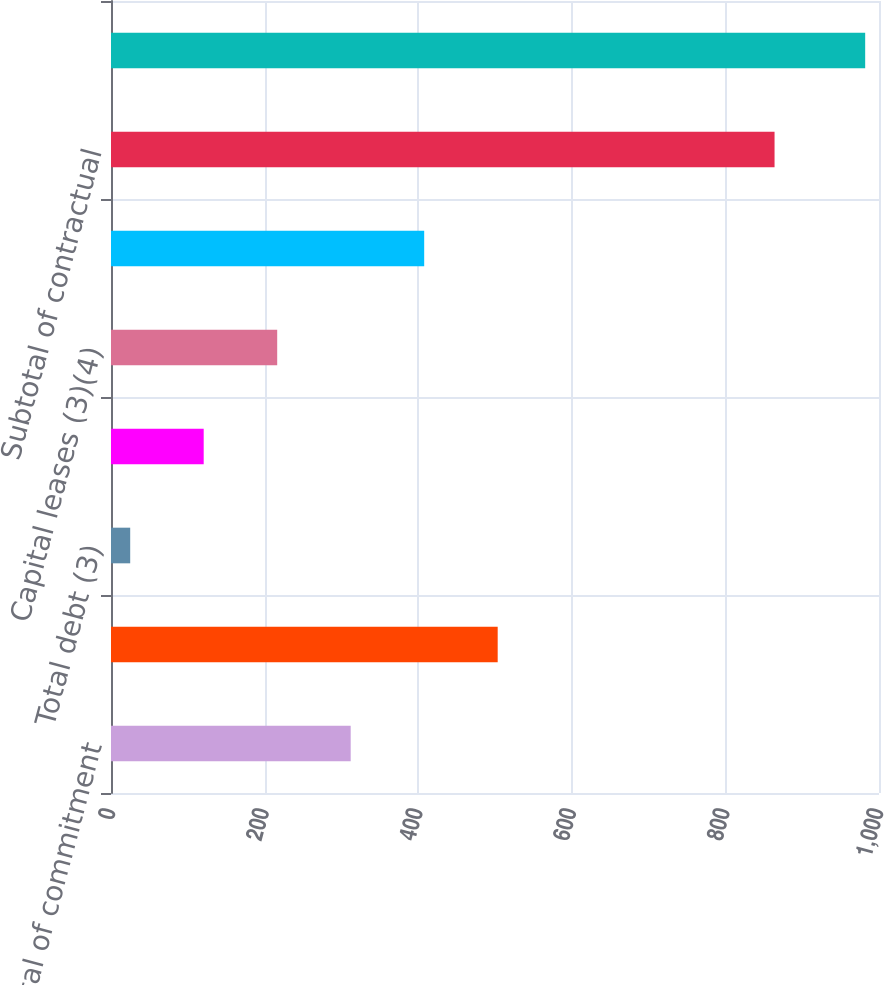Convert chart to OTSL. <chart><loc_0><loc_0><loc_500><loc_500><bar_chart><fcel>Subtotal of commitment<fcel>Purchase obligations<fcel>Total debt (3)<fcel>Minimum rental commitments<fcel>Capital leases (3)(4)<fcel>Interest on long-term debt (5)<fcel>Subtotal of contractual<fcel>Total commitments and<nl><fcel>312.1<fcel>503.5<fcel>25<fcel>120.7<fcel>216.4<fcel>407.8<fcel>864<fcel>982<nl></chart> 